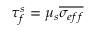Convert formula to latex. <formula><loc_0><loc_0><loc_500><loc_500>\tau _ { f } ^ { s } = \mu _ { s } \overline { { \sigma _ { e f f } } }</formula> 